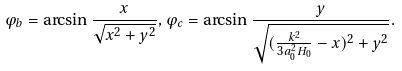<formula> <loc_0><loc_0><loc_500><loc_500>\varphi _ { b } = \arcsin \frac { x } { \sqrt { x ^ { 2 } + y ^ { 2 } } } , \varphi _ { c } = \arcsin \frac { y } { \sqrt { ( \frac { k ^ { 2 } } { 3 a _ { 0 } ^ { 2 } H _ { 0 } } - x ) ^ { 2 } + y ^ { 2 } } } .</formula> 